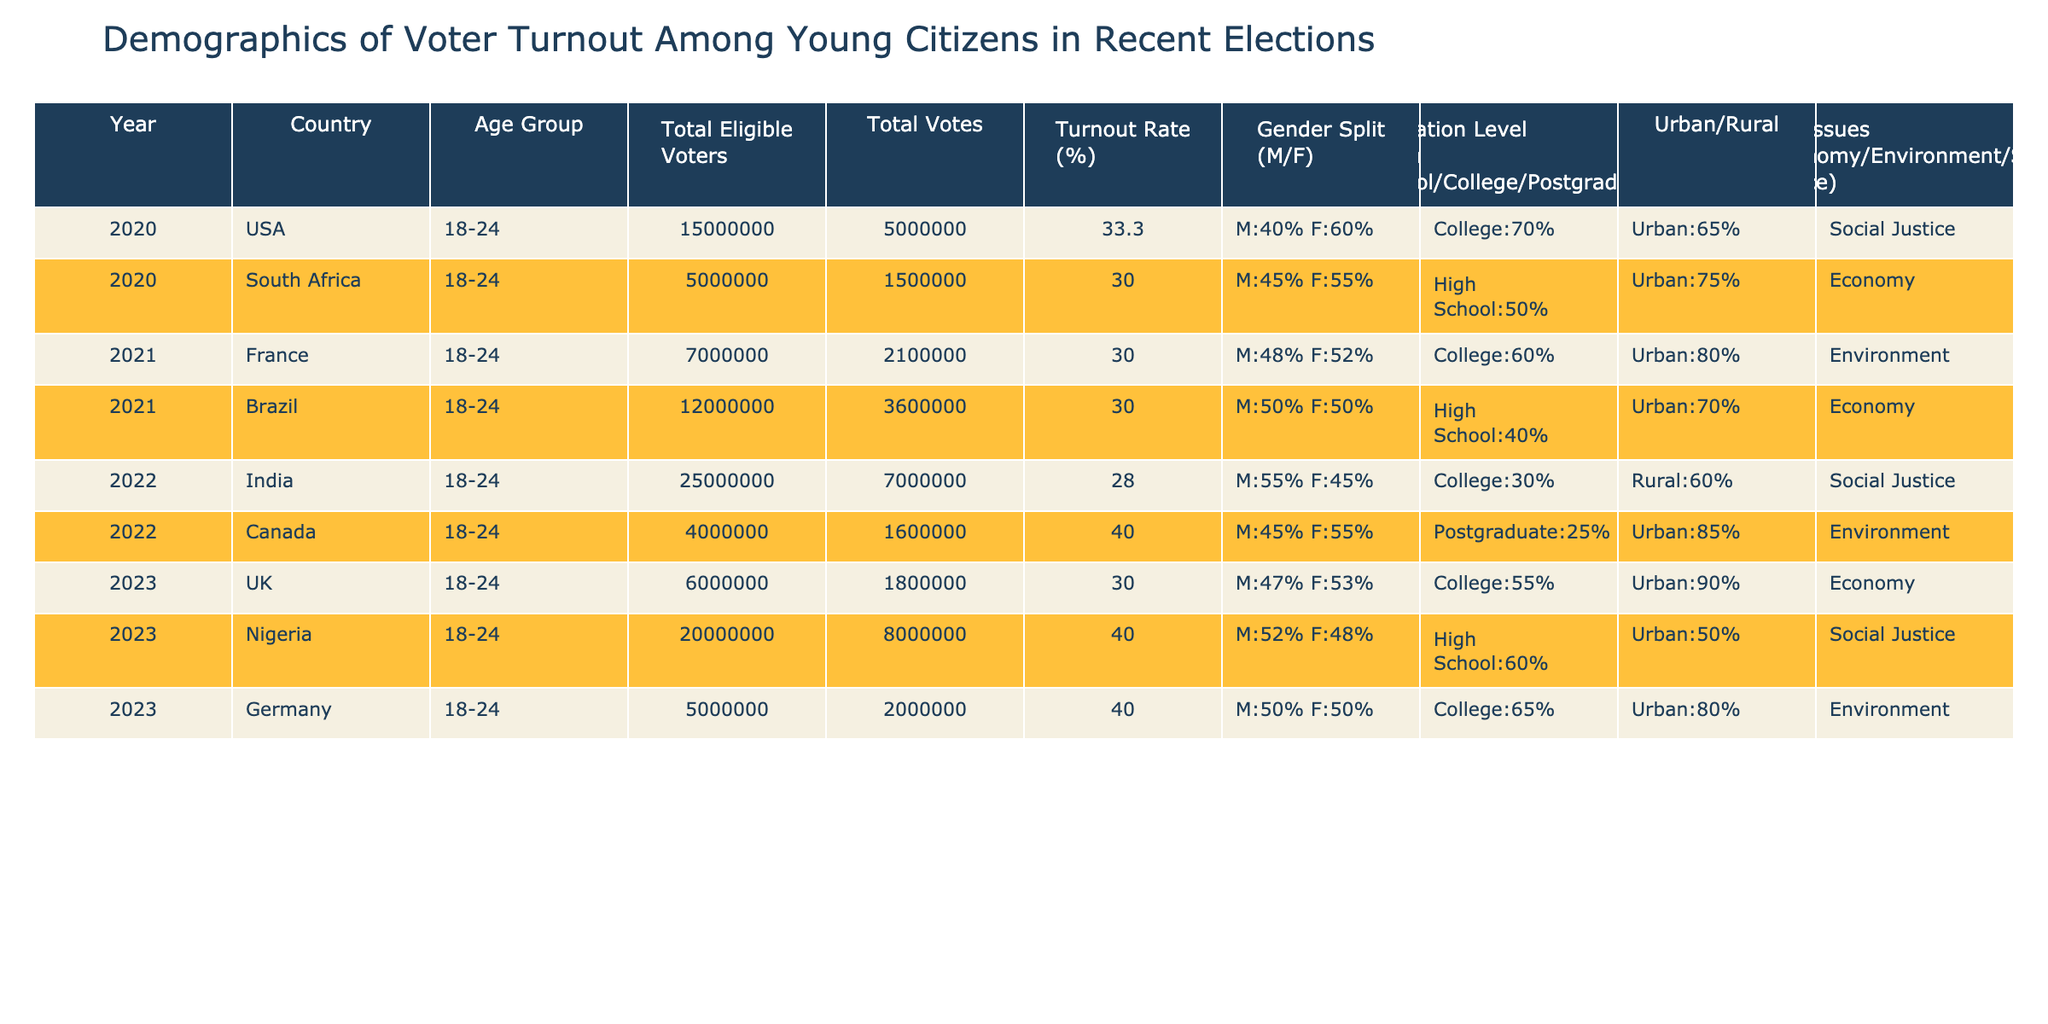What is the voter turnout rate for young citizens in the USA in 2020? The table shows that the voter turnout rate for young citizens aged 18-24 in the USA in 2020 is 33.3%.
Answer: 33.3% Which country had the highest voter turnout rate among young citizens in 2022? By comparing the turnout rates across countries in 2022, India had a voter turnout rate of 28.0%, which is lower than Canada, which had a turnout rate of 40.0%. Therefore, Canada had the highest turnout rate among 18-24 age group in 2022.
Answer: Canada What is the gender split of eligible voters in South Africa in 2020? The table indicates that the gender split in South Africa for eligible voters in 2020 is M:45% and F:55%.
Answer: M:45% F:55% What was the total number of eligible voters in Nigeria in 2023? The table lists the total number of eligible voters in Nigeria in 2023 as 20,000,000.
Answer: 20,000,000 Which country had a higher percentage of college-educated eligible voters, the USA or Germany? The table shows that in the USA, 70% of eligible voters were college-educated while in Germany it was 65%. Thus, the USA had a higher percentage.
Answer: USA What is the average voter turnout rate for all countries listed in 2023? The voter turnout rates for 2023 are 30.0% for the UK and 40.0% for Nigeria. The average is calculated as (30.0 + 40.0) / 2 = 35.0%.
Answer: 35.0% Did any countries have a turnout rate lower than 30%? By analyzing the turnout rates, it’s clear that India in 2022 had a turnout rate of 28.0% which is lower than 30%, confirming that there was at least one country with a low turnout rate.
Answer: Yes Which age group had the lowest turnout rate? Among the age group analysis, India's 18-24 age group in 2022 had the lowest turnout rate of 28.0%, compared to other countries listed in the table.
Answer: 18-24 in India (2022) Is there a correlation between urban living and higher voter turnout among the countries listed? By reviewing the table, the countries with a higher urban percentage (like Canada and Germany) generally have higher turnout rates compared to countries with lower urban percentages, indicating that urban living may correlate with higher voter turnout.
Answer: Yes What is the difference in voter turnout rates between Nigeria and Canada in 2023? The voter turnout rate in Nigeria for 2023 was 40.0%, while in Canada it was 40.0% as well. The difference is 40.0 - 40.0 = 0.0%.
Answer: 0.0% How many total eligible voters were there in the USA and South Africa combined in 2020? The total eligible voters in the USA in 2020 are 15,000,000 and in South Africa, they are 5,000,000. Therefore, the combined total is 15,000,000 + 5,000,000 = 20,000,000.
Answer: 20,000,000 